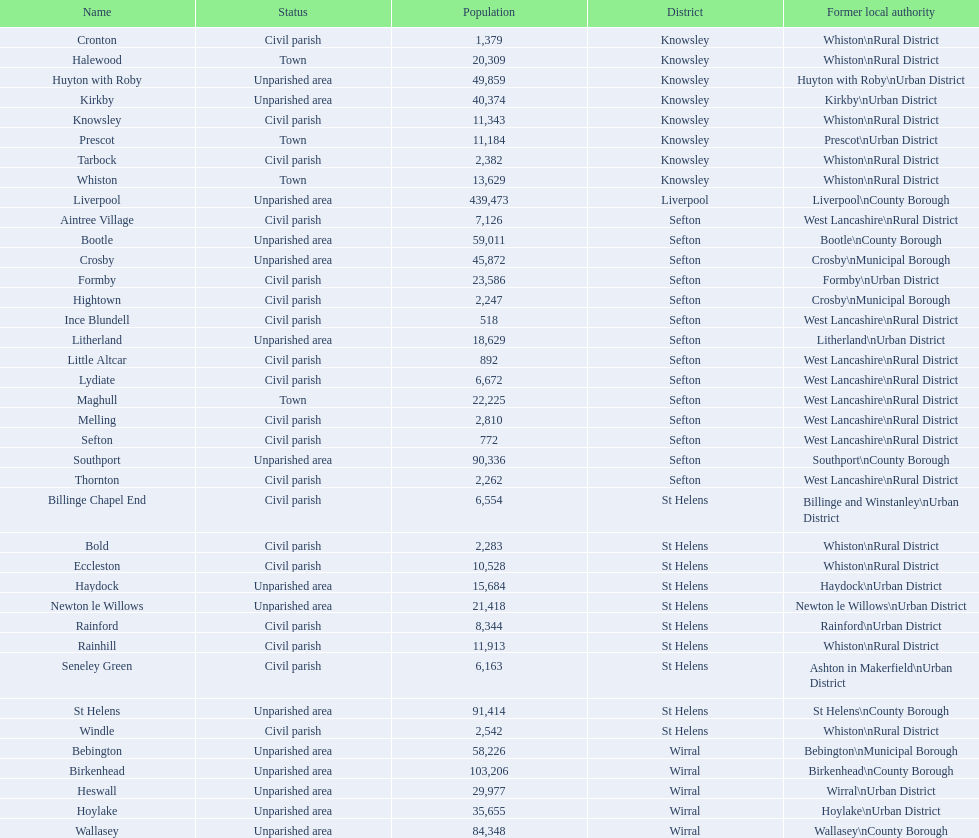Which is a civil parish, aintree village or maghull? Aintree Village. 